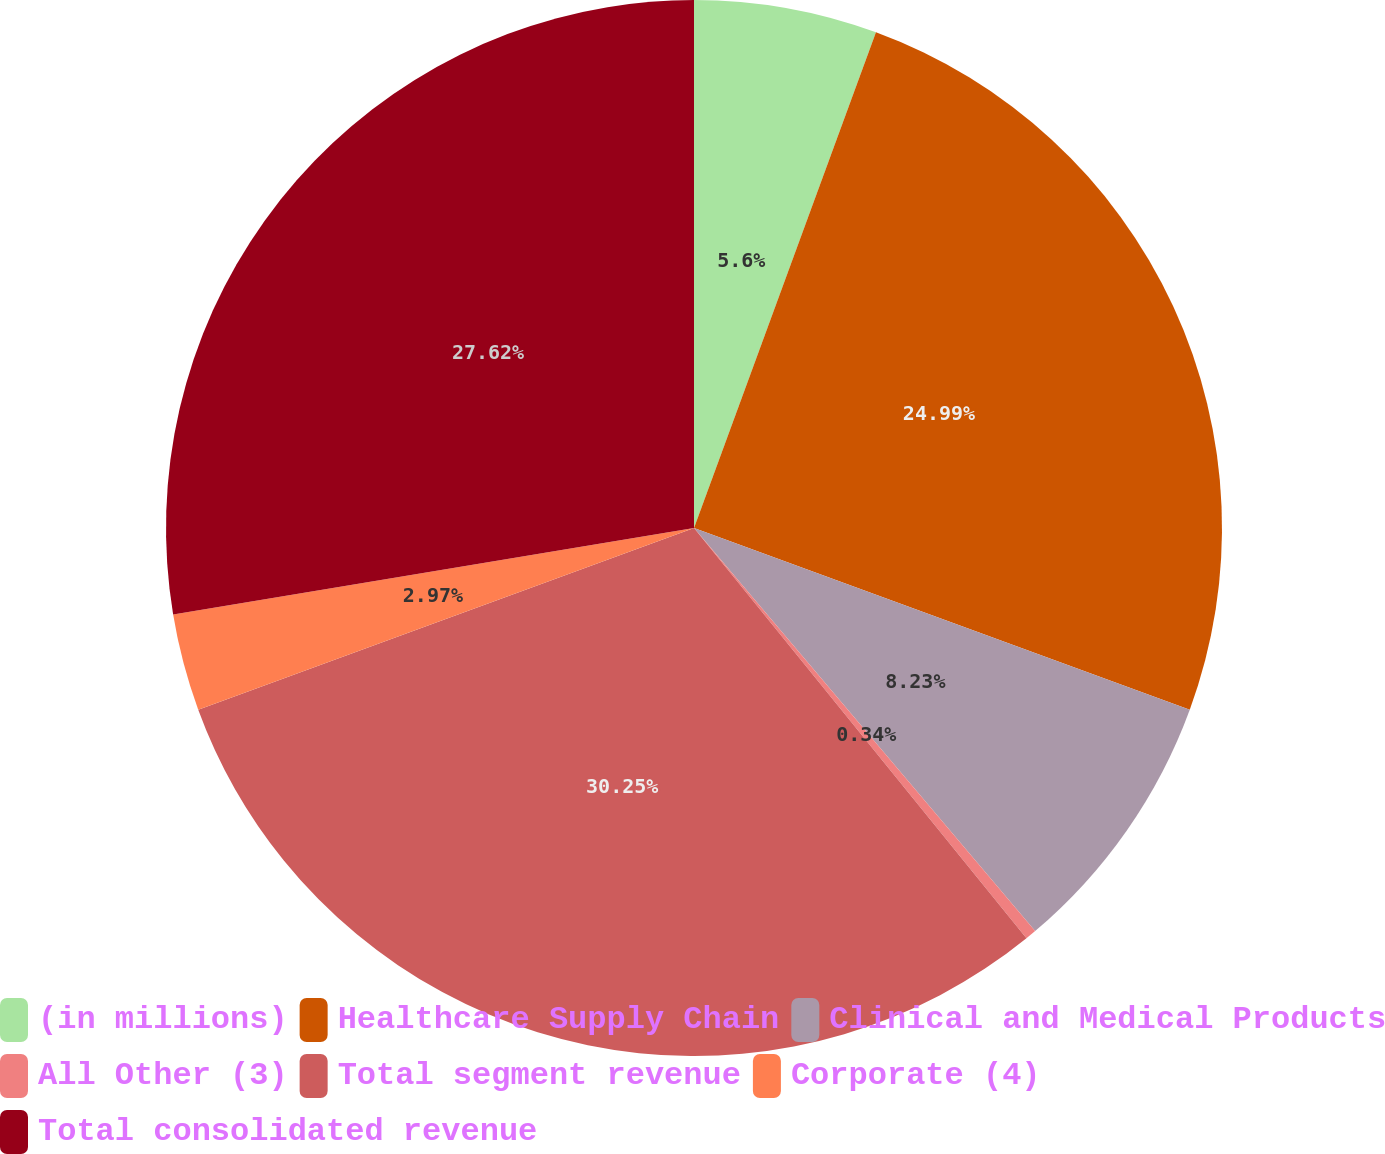<chart> <loc_0><loc_0><loc_500><loc_500><pie_chart><fcel>(in millions)<fcel>Healthcare Supply Chain<fcel>Clinical and Medical Products<fcel>All Other (3)<fcel>Total segment revenue<fcel>Corporate (4)<fcel>Total consolidated revenue<nl><fcel>5.6%<fcel>24.99%<fcel>8.23%<fcel>0.34%<fcel>30.25%<fcel>2.97%<fcel>27.62%<nl></chart> 